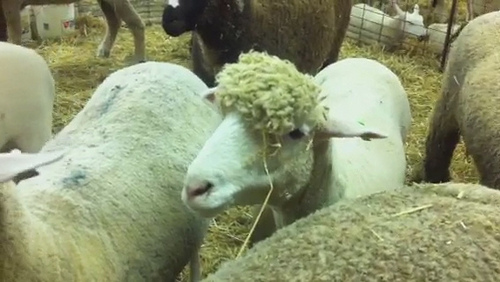If these sheep could talk, what do you think they would say? If these sheep could talk, they might say something like, 'What a beautiful day to graze and enjoy the hay! Have you tried the fresh straw? It's delightful!' They could also share stories about their day, the amusing antics of their pen mates, and perhaps even offer some wisdom that only a sheep could provide. 